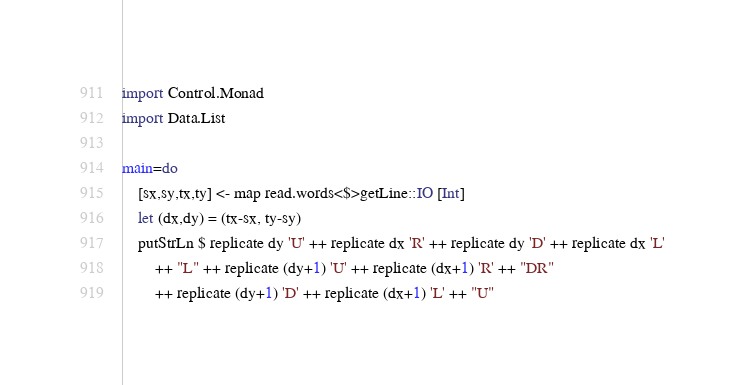Convert code to text. <code><loc_0><loc_0><loc_500><loc_500><_Haskell_>import Control.Monad
import Data.List

main=do
    [sx,sy,tx,ty] <- map read.words<$>getLine::IO [Int]
    let (dx,dy) = (tx-sx, ty-sy)
    putStrLn $ replicate dy 'U' ++ replicate dx 'R' ++ replicate dy 'D' ++ replicate dx 'L'
        ++ "L" ++ replicate (dy+1) 'U' ++ replicate (dx+1) 'R' ++ "DR"
        ++ replicate (dy+1) 'D' ++ replicate (dx+1) 'L' ++ "U"
</code> 